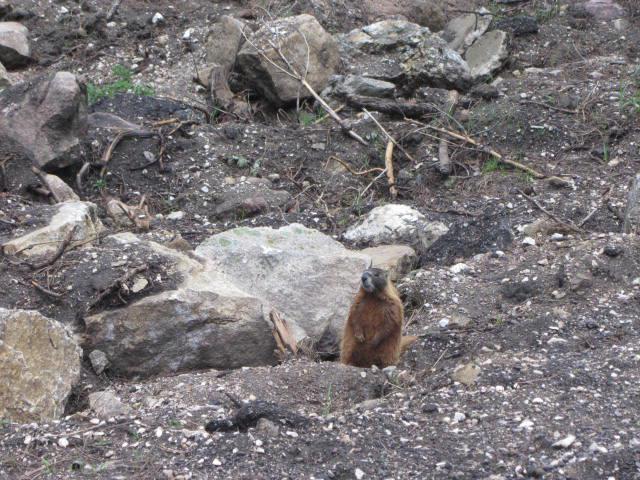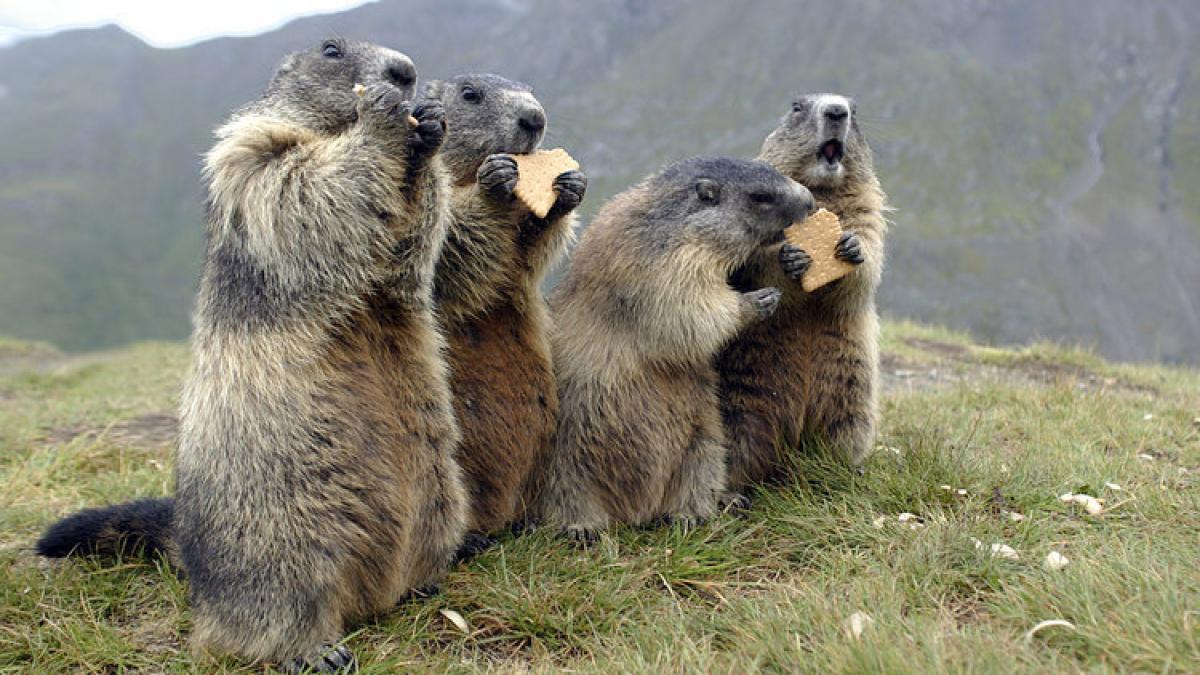The first image is the image on the left, the second image is the image on the right. Analyze the images presented: Is the assertion "An image shows a row of four prairie dog type animals, standing upright eating crackers." valid? Answer yes or no. Yes. 